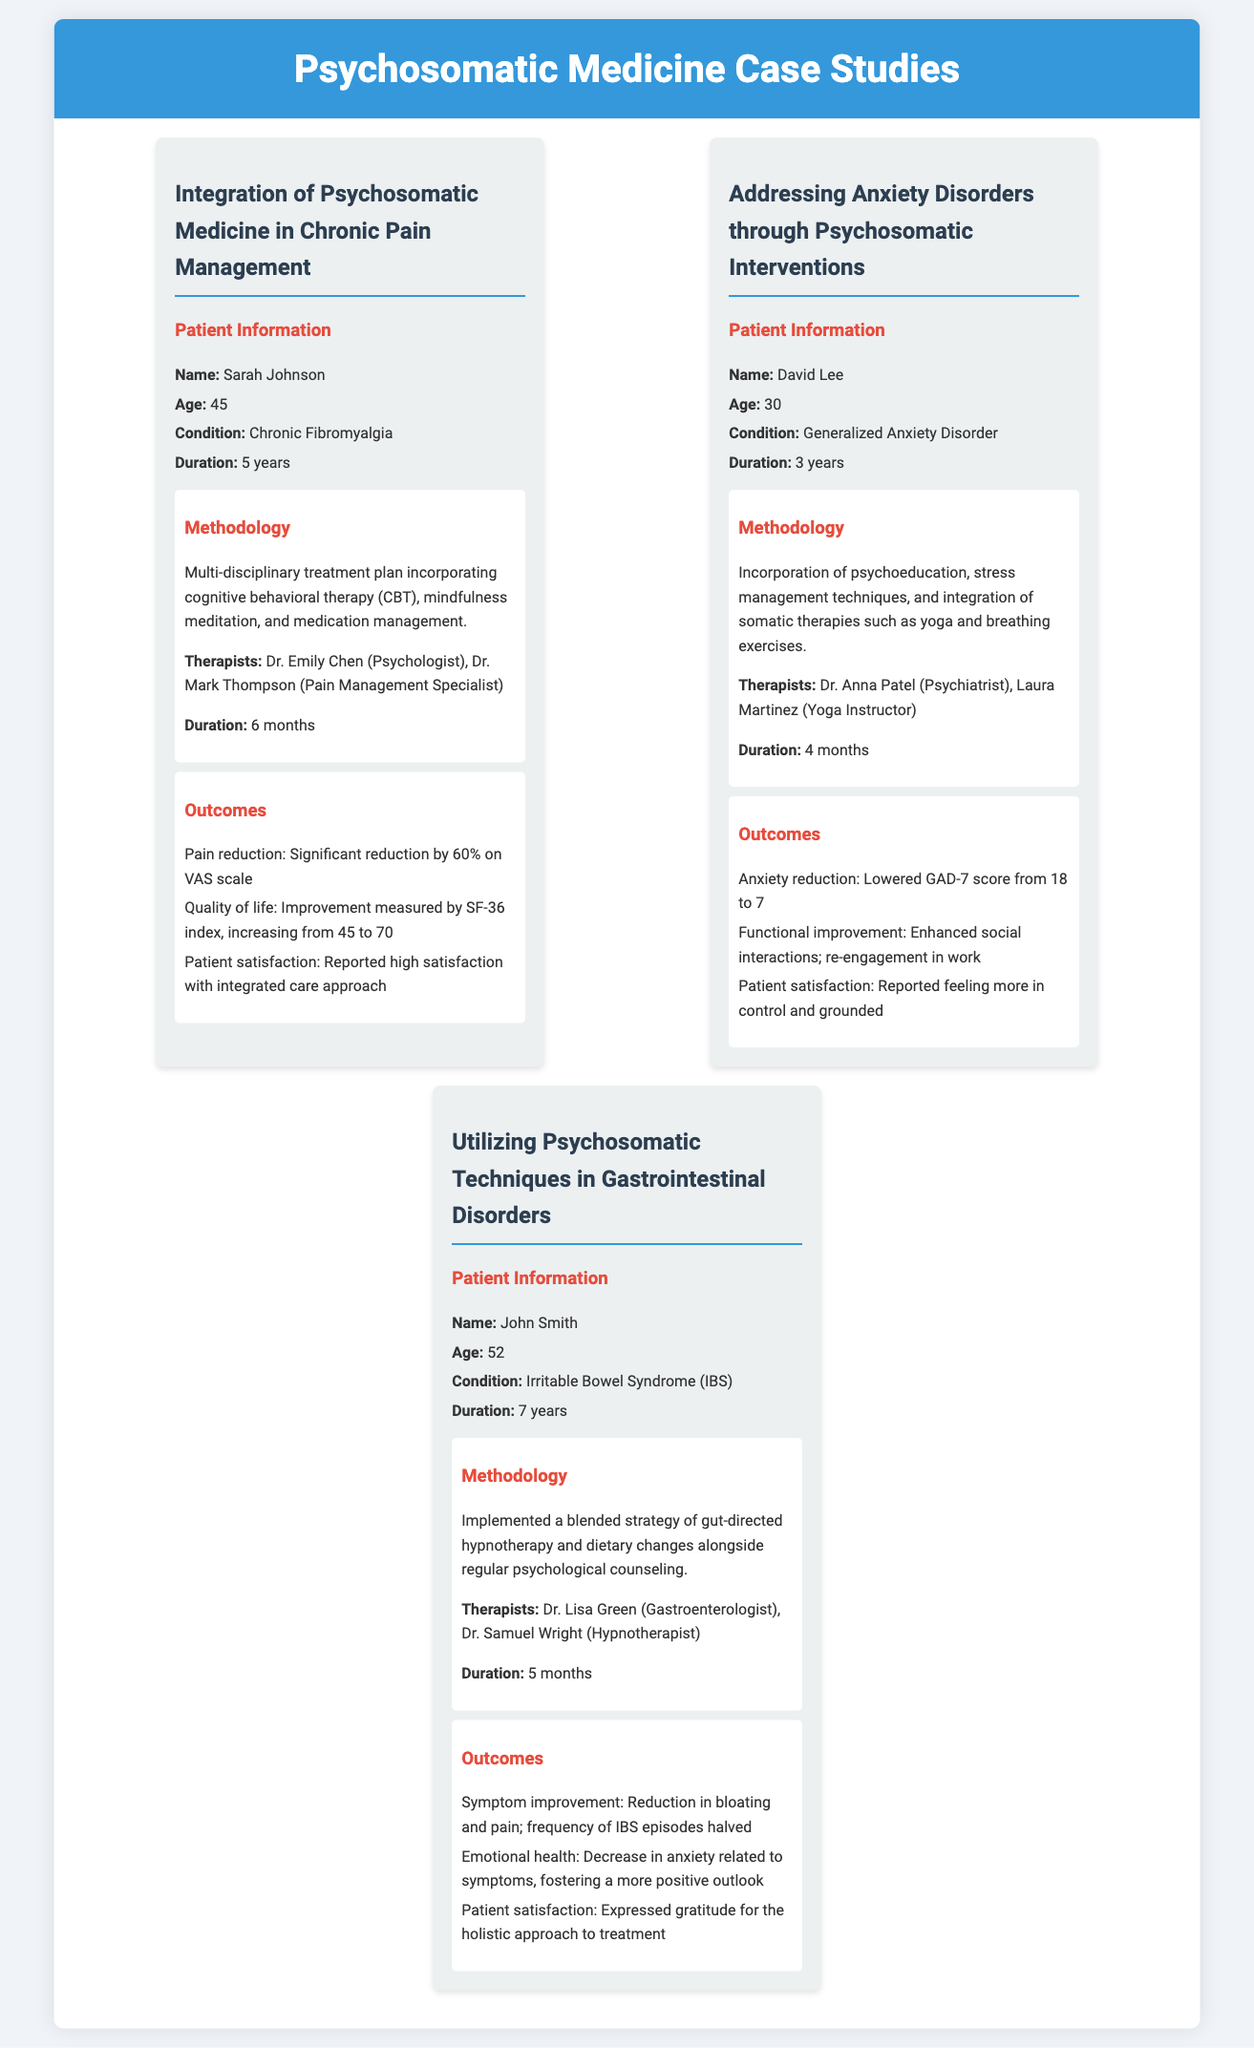What is the name of the first patient? The name of the first patient is listed under the case study of chronic pain management.
Answer: Sarah Johnson How long did David Lee suffer from his condition? The document states that David Lee has a duration of 3 years for his condition.
Answer: 3 years What technique was used alongside dietary changes for John Smith? The document specifies that gut-directed hypnotherapy was implemented alongside dietary changes.
Answer: Gut-directed hypnotherapy What was the significant reduction percentage in Sarah Johnson's pain? The outcome section details a significant reduction by 60% on the VAS scale for Sarah Johnson.
Answer: 60% Who was the psychiatrist involved in David Lee's treatment? The document lists Dr. Anna Patel as the psychiatrist for David Lee's treatment.
Answer: Dr. Anna Patel What was the initial GAD-7 score for David Lee? The document indicates that David Lee's initial GAD-7 score was 18.
Answer: 18 How many months did John Smith undergo treatment? The document states that John Smith's treatment duration was 5 months.
Answer: 5 months Which patient reported high satisfaction with the integrated care approach? The outcomes for Sarah Johnson mention her high satisfaction with the care approach.
Answer: Sarah Johnson What condition does John Smith have? The document specifies John Smith's condition as Irritable Bowel Syndrome (IBS).
Answer: Irritable Bowel Syndrome (IBS) What was the increase in the SF-36 index for Sarah Johnson? The improvement measured by the SF-36 index increased from 45 to 70 for Sarah Johnson.
Answer: 25 points 